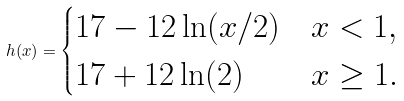Convert formula to latex. <formula><loc_0><loc_0><loc_500><loc_500>h ( x ) = \begin{cases} 1 7 - 1 2 \ln ( x / 2 ) & x < 1 , \\ 1 7 + 1 2 \ln ( 2 ) & x \geq 1 . \end{cases}</formula> 